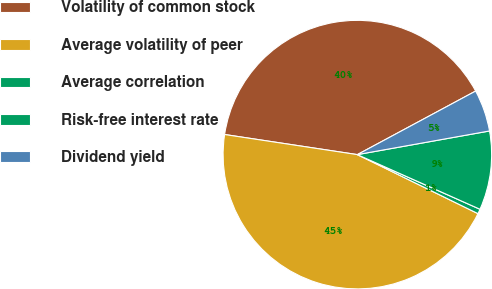Convert chart to OTSL. <chart><loc_0><loc_0><loc_500><loc_500><pie_chart><fcel>Volatility of common stock<fcel>Average volatility of peer<fcel>Average correlation<fcel>Risk-free interest rate<fcel>Dividend yield<nl><fcel>39.76%<fcel>45.15%<fcel>0.57%<fcel>9.49%<fcel>5.03%<nl></chart> 